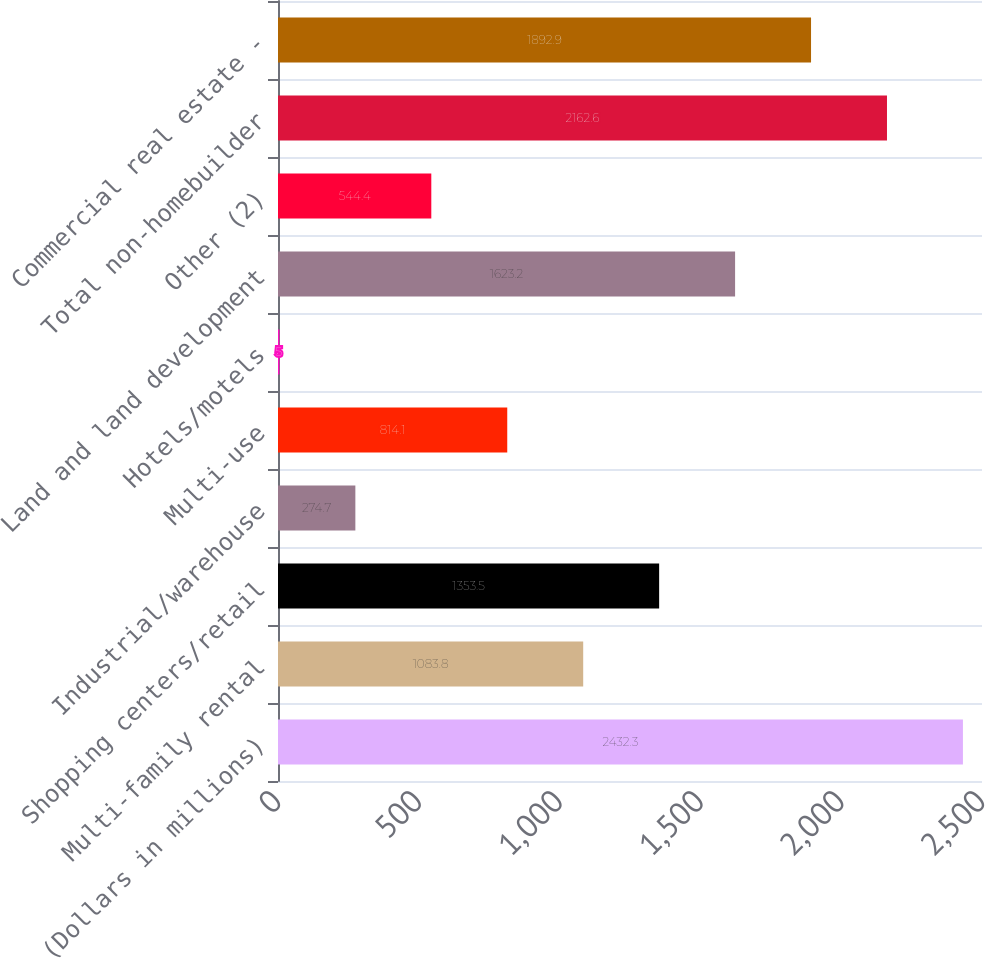<chart> <loc_0><loc_0><loc_500><loc_500><bar_chart><fcel>(Dollars in millions)<fcel>Multi-family rental<fcel>Shopping centers/retail<fcel>Industrial/warehouse<fcel>Multi-use<fcel>Hotels/motels<fcel>Land and land development<fcel>Other (2)<fcel>Total non-homebuilder<fcel>Commercial real estate -<nl><fcel>2432.3<fcel>1083.8<fcel>1353.5<fcel>274.7<fcel>814.1<fcel>5<fcel>1623.2<fcel>544.4<fcel>2162.6<fcel>1892.9<nl></chart> 